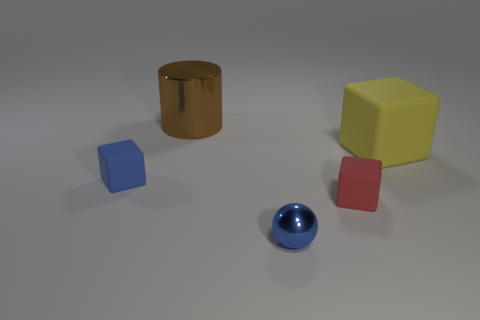Add 4 yellow balls. How many objects exist? 9 Subtract all cubes. How many objects are left? 2 Add 5 green cubes. How many green cubes exist? 5 Subtract 0 gray blocks. How many objects are left? 5 Subtract all brown cylinders. Subtract all tiny rubber cubes. How many objects are left? 2 Add 2 red matte cubes. How many red matte cubes are left? 3 